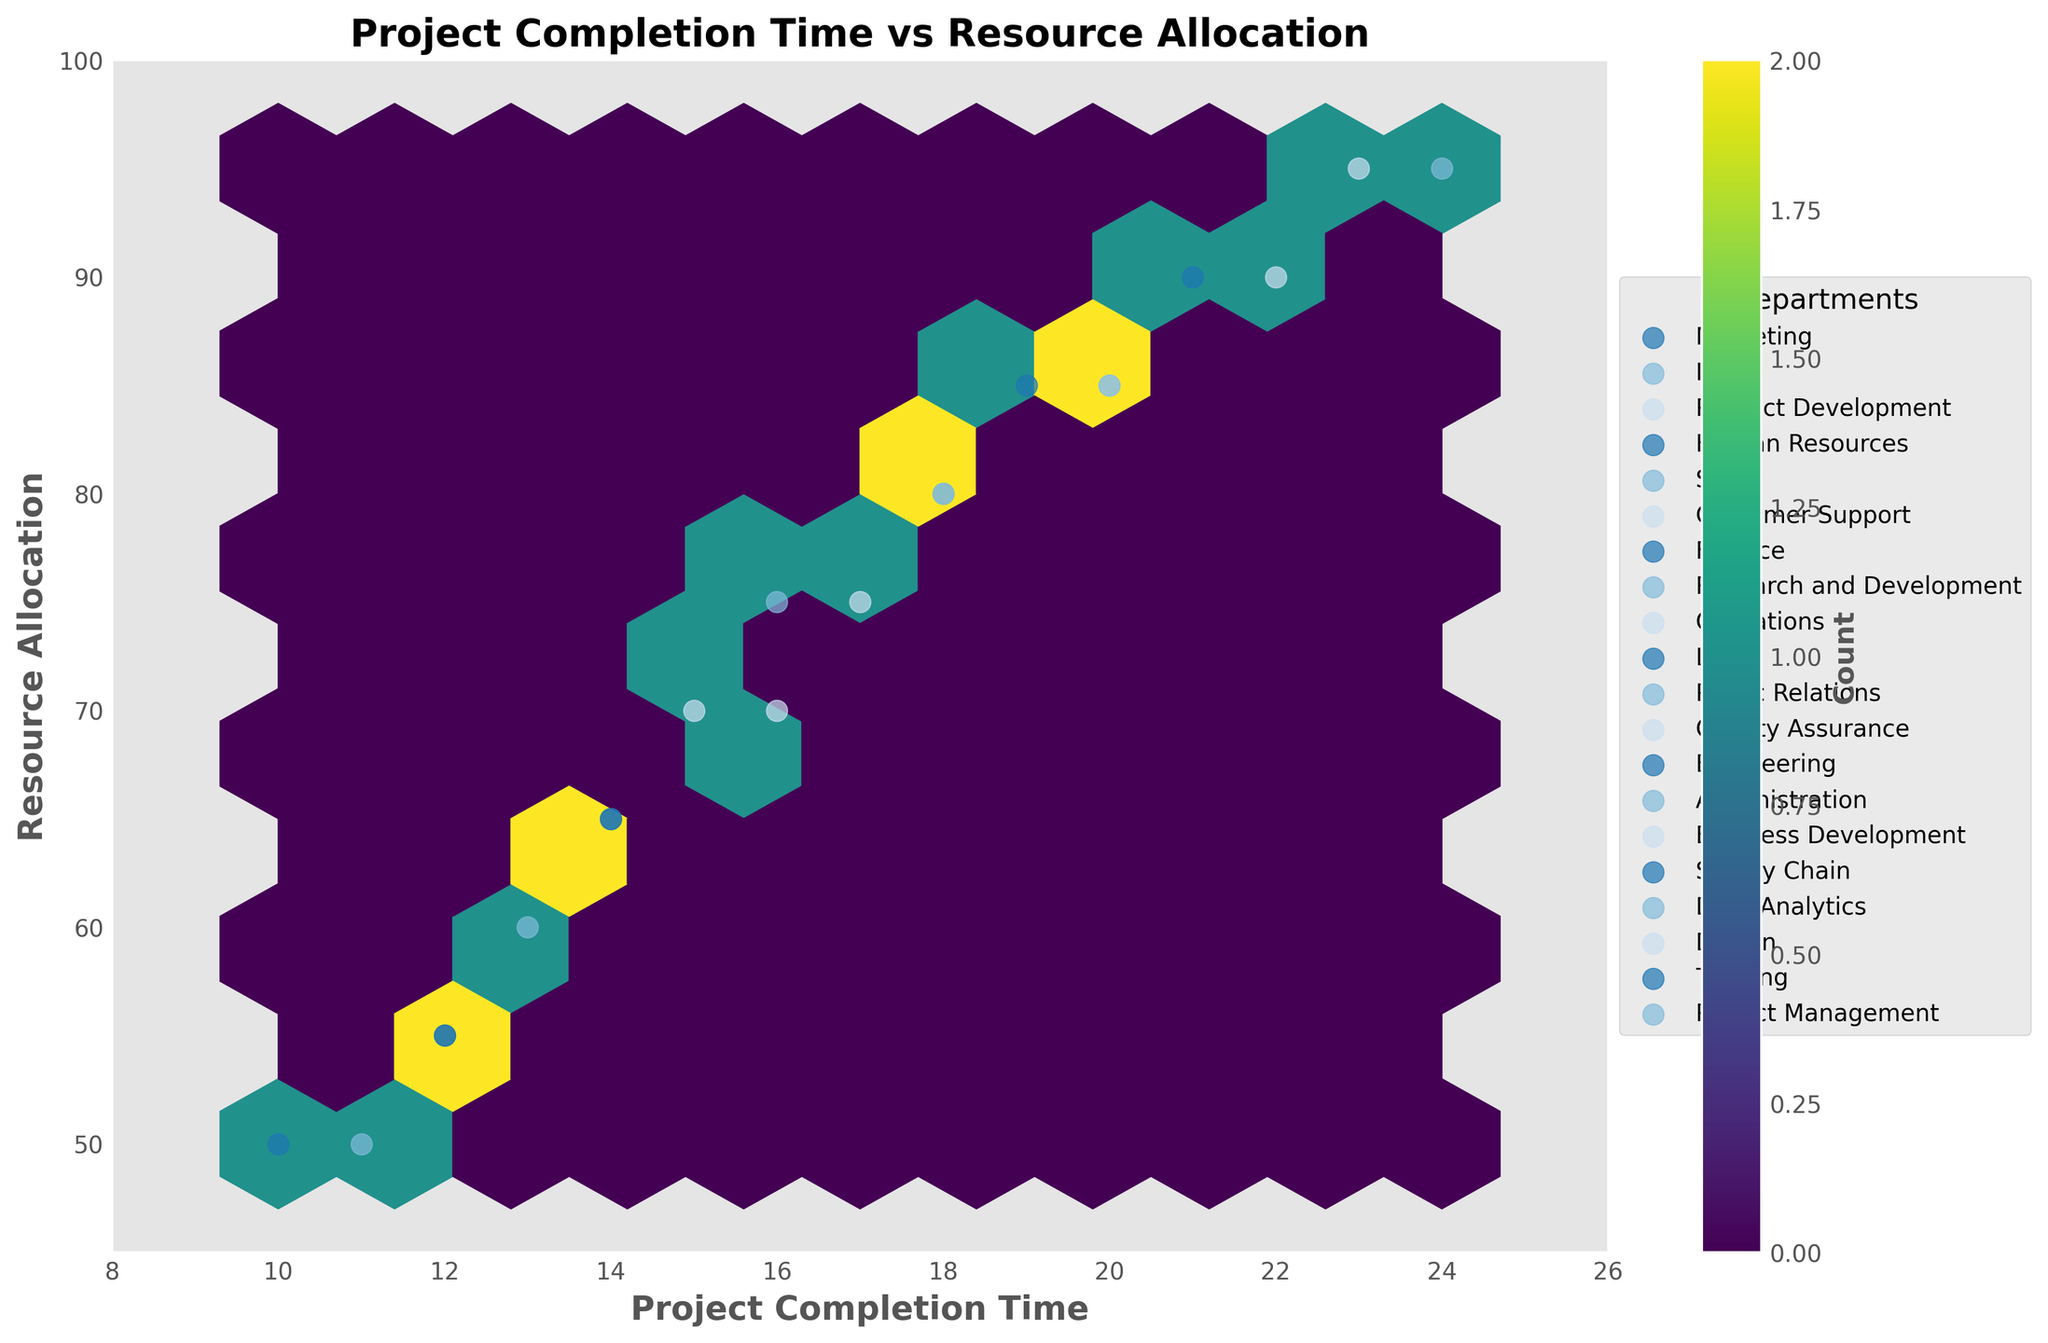What is the title of the hexbin plot? The title of the plot is placed at the top center of the figure and is intended to describe what the visual represents.
Answer: Project Completion Time vs Resource Allocation How many departments are depicted in the plot? Each unique department is labeled in the legend on the right side of the plot. By counting the different labels, you can determine the number of departments.
Answer: 20 What is the range of project completion times depicted in the plot? The range of project completion times is shown along the x-axis. The plot is set to display project completion times within limits indicated by the axis.
Answer: 8 to 26 Which department has a project completion time of 24 days and resource allocation of 95? The department can be identified by finding the data point at the coordinates (24, 95) and checking the legend or labels.
Answer: Research and Development What is the most common hexbin count according to the color bar? The color bar represents the count of data points within each hexbin. The most frequently appearing color on the plot can be checked against the color bar to find the corresponding count.
Answer: Varies (check the color bar) What department shows completion times between 18-20 days and what is their resource allocation? Points within this range on the x-axis should be identified and matched with their respective y-axis values and department labels.
Answer: IT, Customer Support, Data Analytics (Resource allocation: 80, 85, 80 respectively) Which department has the lowest resource allocation, and what is its project completion time? The lowest resource allocation is identified on the y-axis, and the corresponding department and project completion time are checked against the data points and labels.
Answer: Finance, 50 days Are there more departments with project completion times above 20 days or below 20 days? By counting the departments for points above and below 20 on the x-axis and referencing the legend, the comparison can be made.
Answer: Below 20 days Which two departments have the same project completion times of 14 days but different resource allocations? Identify the data points at 14 days on the x-axis, then check different y-axis values and department labels.
Answer: Marketing and Supply Chain (Resource allocation: 65 and 65) For departments with a resource allocation of 85, what are their project completion times? Points with y-axis value of 85 should be identified on the x-axis and cross-referenced with the department labels.
Answer: Customer Support, Project Management (Completion times: 20 days each) 